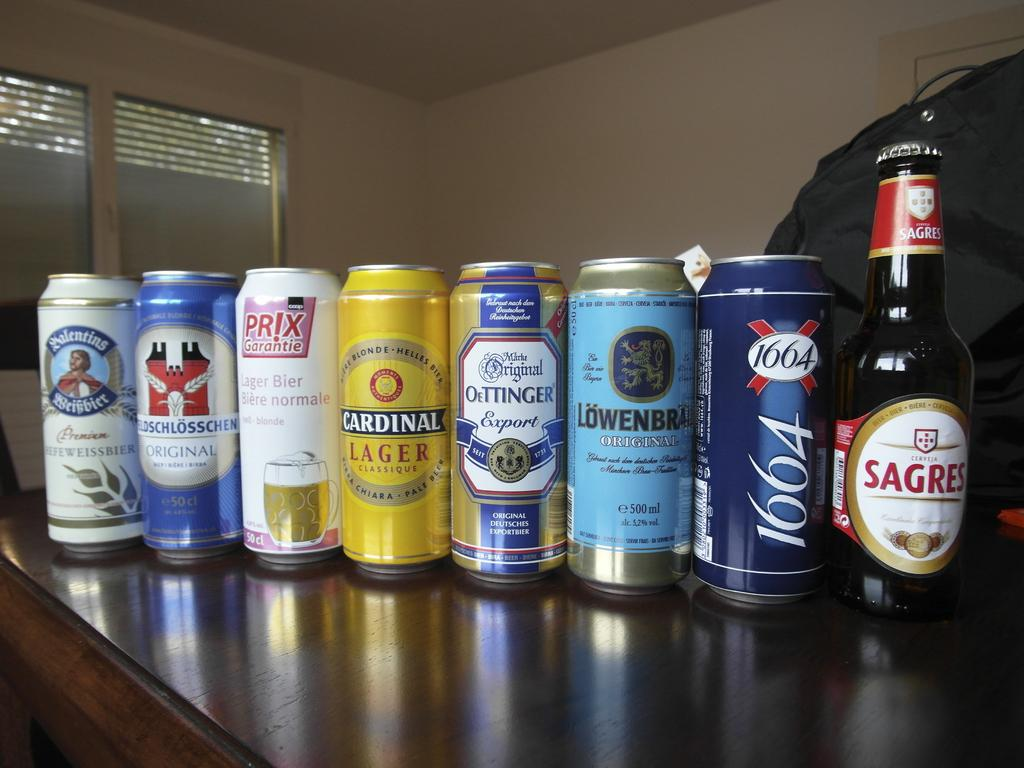<image>
Relay a brief, clear account of the picture shown. Amongst other cans and a bottle is a yellow can of Cardinal Lager. 